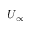Convert formula to latex. <formula><loc_0><loc_0><loc_500><loc_500>U _ { \infty }</formula> 